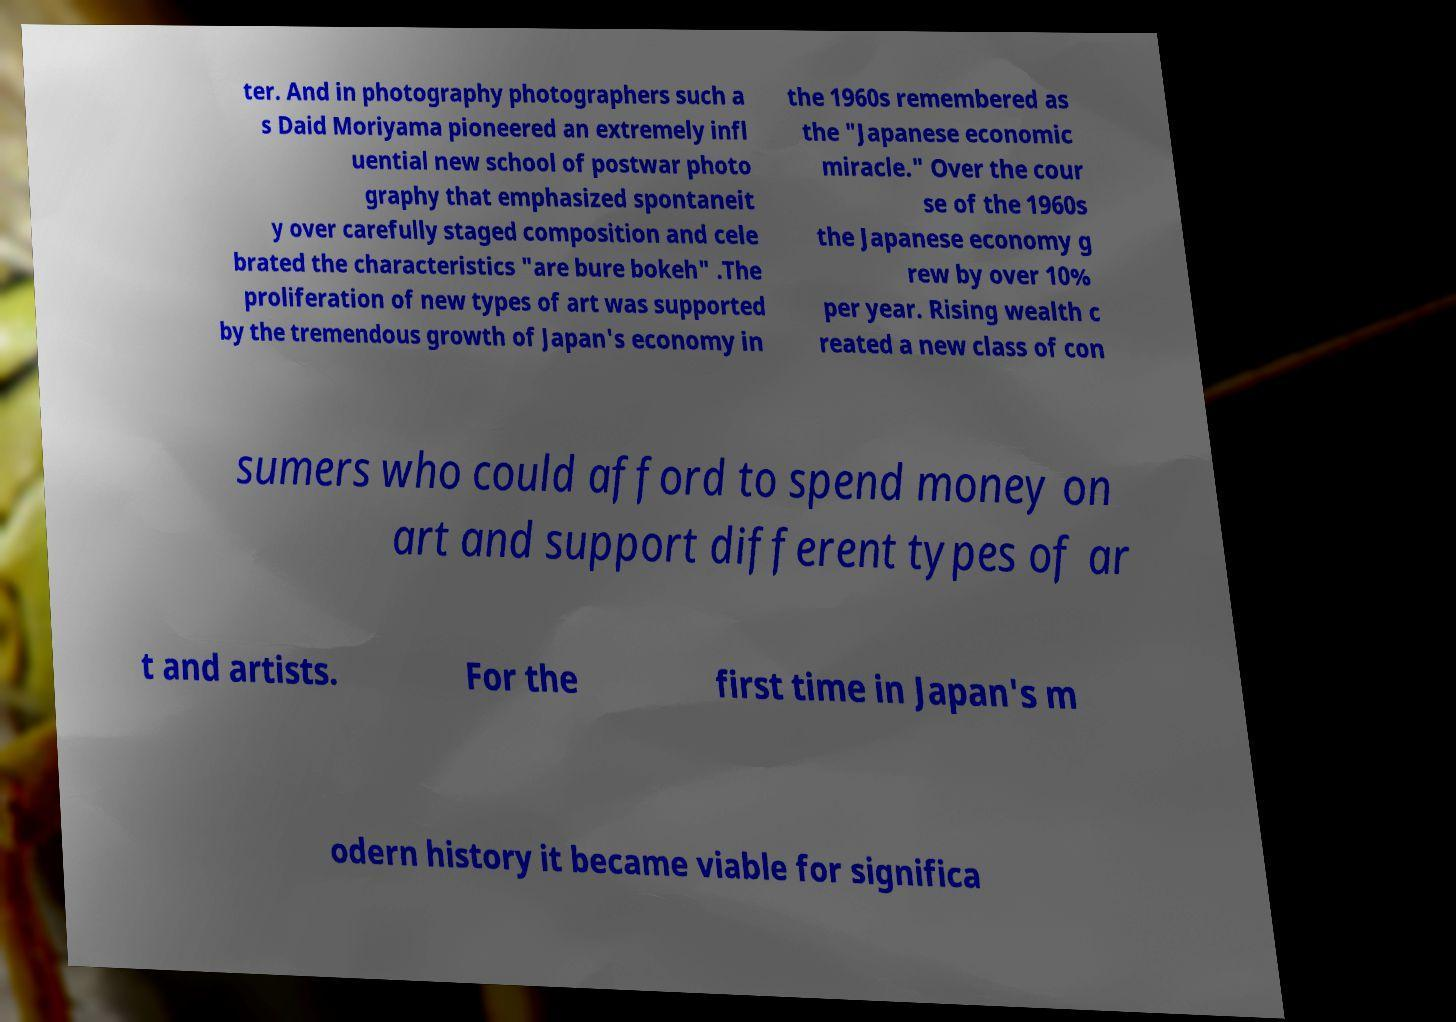Could you extract and type out the text from this image? ter. And in photography photographers such a s Daid Moriyama pioneered an extremely infl uential new school of postwar photo graphy that emphasized spontaneit y over carefully staged composition and cele brated the characteristics "are bure bokeh" .The proliferation of new types of art was supported by the tremendous growth of Japan's economy in the 1960s remembered as the "Japanese economic miracle." Over the cour se of the 1960s the Japanese economy g rew by over 10% per year. Rising wealth c reated a new class of con sumers who could afford to spend money on art and support different types of ar t and artists. For the first time in Japan's m odern history it became viable for significa 